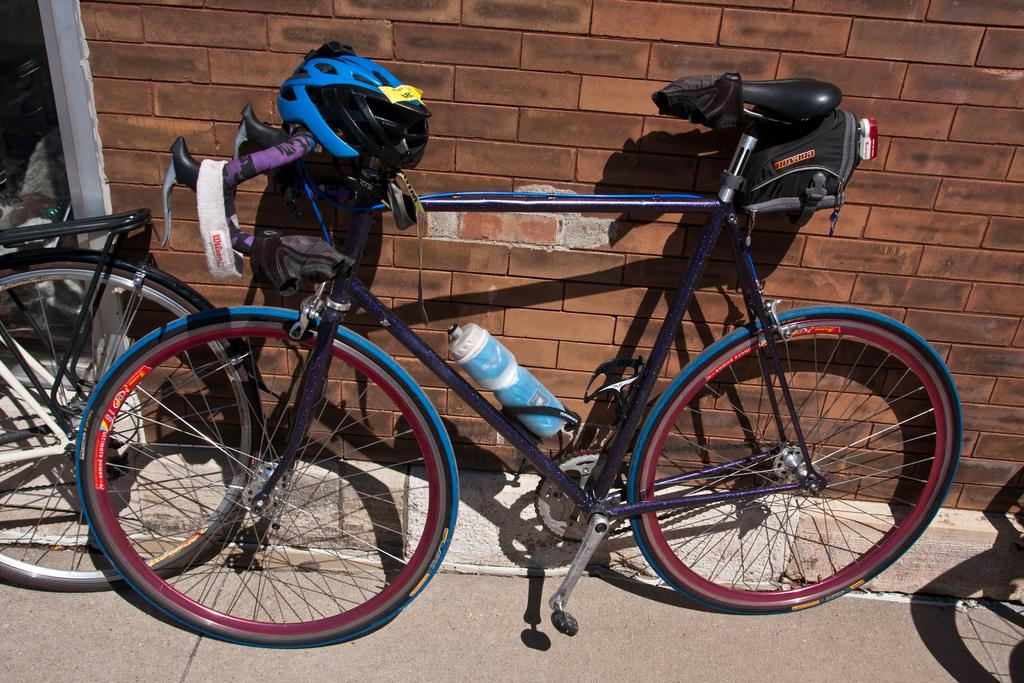What is located in the middle of the image? There are cycles in the middle of the image. What can be seen in the background of the image? There is a wall in the background of the image. Where is the boat located in the image? There is no boat present in the image. What type of cookware is visible in the image? There is no cookware present in the image. 